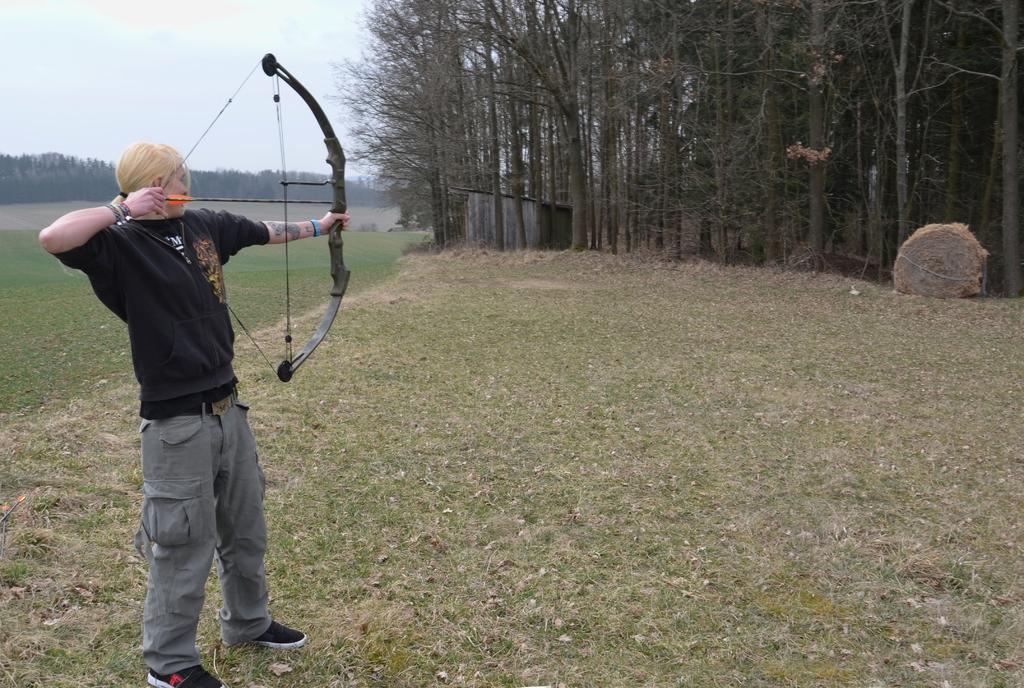Can you describe this image briefly? On the left side, there is a person in black color T-shirt, holding a thread and an arrow with a hand, holding a bow with the other hand, looking an object and standing on the ground, on which there is grass. In the background, there are trees, a shelter, an object and grass on the ground and there are clouds in the sky. 